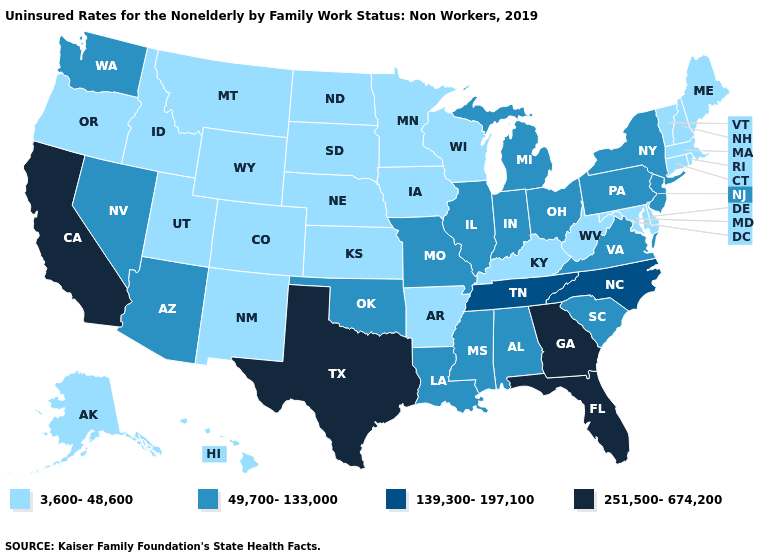Among the states that border Vermont , does New York have the lowest value?
Keep it brief. No. Which states have the lowest value in the USA?
Answer briefly. Alaska, Arkansas, Colorado, Connecticut, Delaware, Hawaii, Idaho, Iowa, Kansas, Kentucky, Maine, Maryland, Massachusetts, Minnesota, Montana, Nebraska, New Hampshire, New Mexico, North Dakota, Oregon, Rhode Island, South Dakota, Utah, Vermont, West Virginia, Wisconsin, Wyoming. Name the states that have a value in the range 251,500-674,200?
Keep it brief. California, Florida, Georgia, Texas. Which states have the lowest value in the USA?
Short answer required. Alaska, Arkansas, Colorado, Connecticut, Delaware, Hawaii, Idaho, Iowa, Kansas, Kentucky, Maine, Maryland, Massachusetts, Minnesota, Montana, Nebraska, New Hampshire, New Mexico, North Dakota, Oregon, Rhode Island, South Dakota, Utah, Vermont, West Virginia, Wisconsin, Wyoming. Does the map have missing data?
Short answer required. No. Among the states that border Nevada , which have the lowest value?
Keep it brief. Idaho, Oregon, Utah. Which states have the highest value in the USA?
Answer briefly. California, Florida, Georgia, Texas. Does the map have missing data?
Concise answer only. No. How many symbols are there in the legend?
Answer briefly. 4. Name the states that have a value in the range 251,500-674,200?
Give a very brief answer. California, Florida, Georgia, Texas. What is the lowest value in states that border Idaho?
Quick response, please. 3,600-48,600. Which states have the lowest value in the USA?
Give a very brief answer. Alaska, Arkansas, Colorado, Connecticut, Delaware, Hawaii, Idaho, Iowa, Kansas, Kentucky, Maine, Maryland, Massachusetts, Minnesota, Montana, Nebraska, New Hampshire, New Mexico, North Dakota, Oregon, Rhode Island, South Dakota, Utah, Vermont, West Virginia, Wisconsin, Wyoming. Name the states that have a value in the range 3,600-48,600?
Be succinct. Alaska, Arkansas, Colorado, Connecticut, Delaware, Hawaii, Idaho, Iowa, Kansas, Kentucky, Maine, Maryland, Massachusetts, Minnesota, Montana, Nebraska, New Hampshire, New Mexico, North Dakota, Oregon, Rhode Island, South Dakota, Utah, Vermont, West Virginia, Wisconsin, Wyoming. What is the highest value in the USA?
Answer briefly. 251,500-674,200. What is the value of New Hampshire?
Short answer required. 3,600-48,600. 